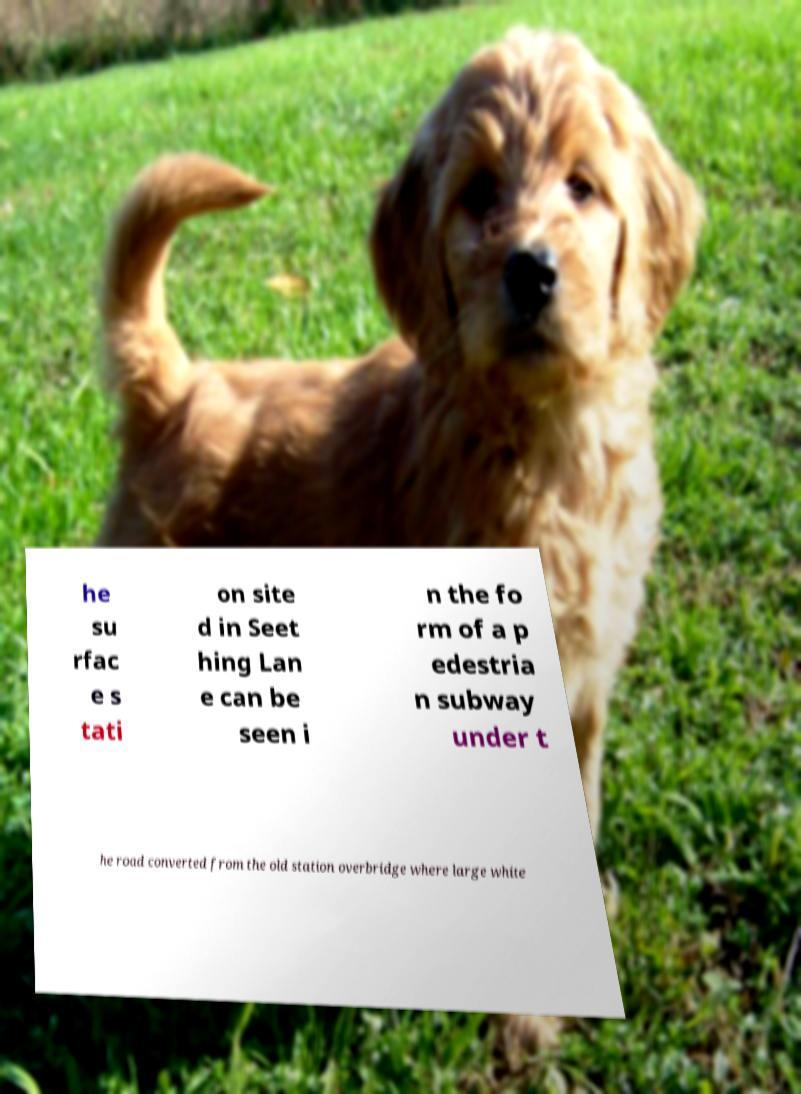Could you extract and type out the text from this image? he su rfac e s tati on site d in Seet hing Lan e can be seen i n the fo rm of a p edestria n subway under t he road converted from the old station overbridge where large white 